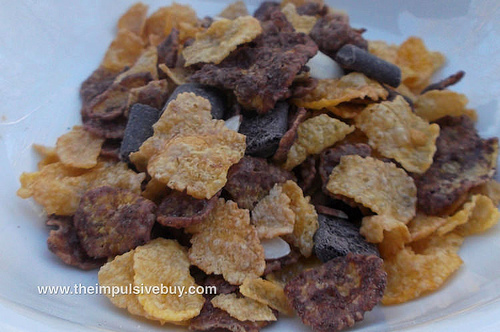<image>
Is there a bowl under the chocolate? Yes. The bowl is positioned underneath the chocolate, with the chocolate above it in the vertical space. 